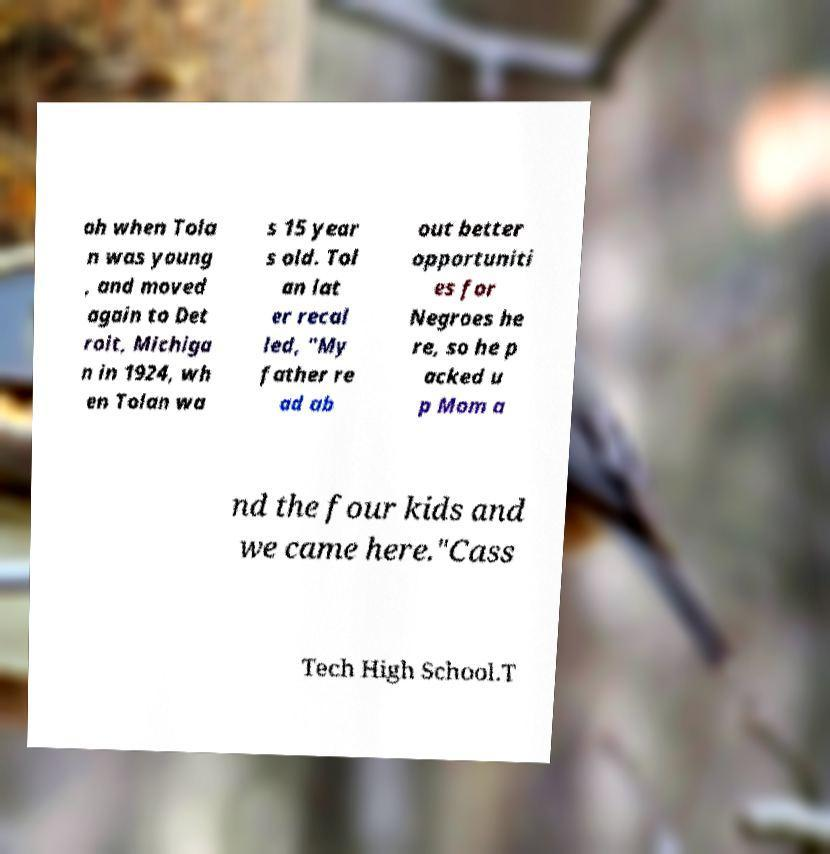Could you extract and type out the text from this image? ah when Tola n was young , and moved again to Det roit, Michiga n in 1924, wh en Tolan wa s 15 year s old. Tol an lat er recal led, "My father re ad ab out better opportuniti es for Negroes he re, so he p acked u p Mom a nd the four kids and we came here."Cass Tech High School.T 